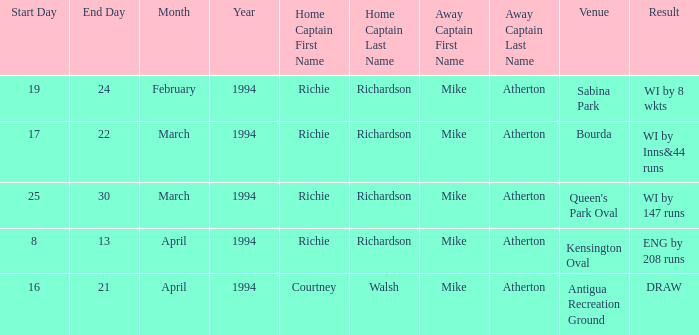What is the result of Courtney Walsh ? DRAW. 